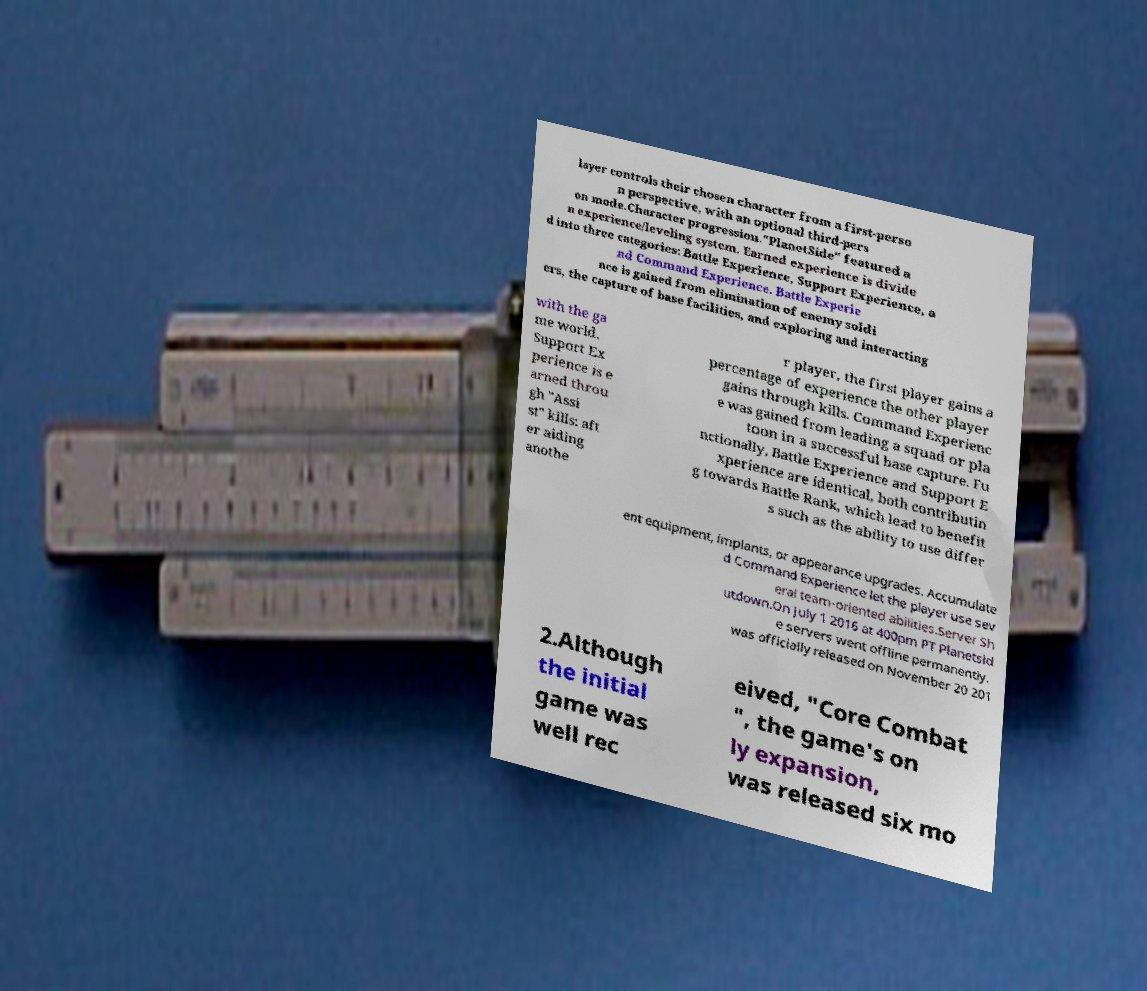Please identify and transcribe the text found in this image. layer controls their chosen character from a first-perso n perspective, with an optional third-pers on mode.Character progression."PlanetSide" featured a n experience/leveling system. Earned experience is divide d into three categories: Battle Experience, Support Experience, a nd Command Experience. Battle Experie nce is gained from elimination of enemy soldi ers, the capture of base facilities, and exploring and interacting with the ga me world. Support Ex perience is e arned throu gh "Assi st" kills: aft er aiding anothe r player, the first player gains a percentage of experience the other player gains through kills. Command Experienc e was gained from leading a squad or pla toon in a successful base capture. Fu nctionally, Battle Experience and Support E xperience are identical, both contributin g towards Battle Rank, which lead to benefit s such as the ability to use differ ent equipment, implants, or appearance upgrades. Accumulate d Command Experience let the player use sev eral team-oriented abilities.Server Sh utdown.On July 1 2016 at 400pm PT Planetsid e servers went offline permanently. was officially released on November 20 201 2.Although the initial game was well rec eived, "Core Combat ", the game's on ly expansion, was released six mo 